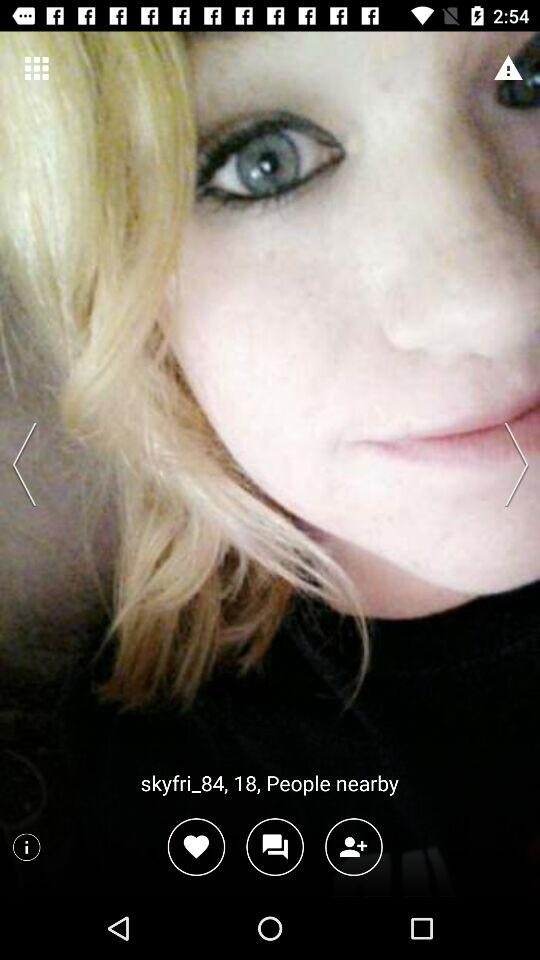What is the age of "skyfri_84"? The age of "skyfri_84" is 18 years. 